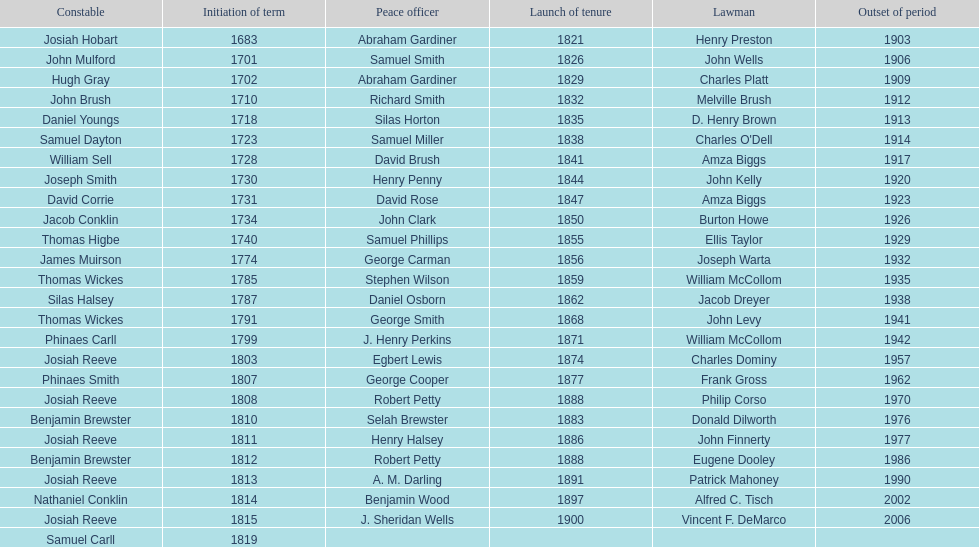What is the total number of sheriffs that were in office in suffolk county between 1903 and 1957? 17. 